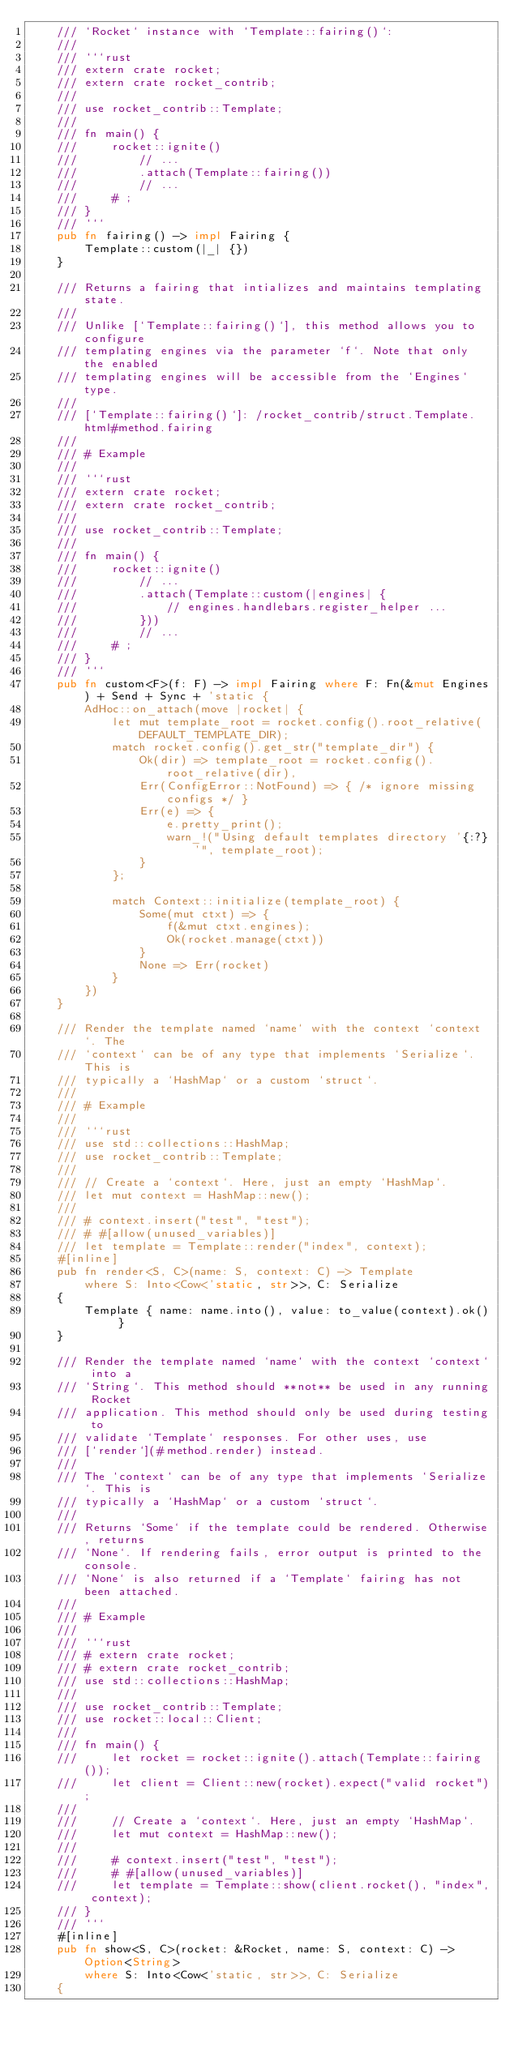Convert code to text. <code><loc_0><loc_0><loc_500><loc_500><_Rust_>    /// `Rocket` instance with `Template::fairing()`:
    ///
    /// ```rust
    /// extern crate rocket;
    /// extern crate rocket_contrib;
    ///
    /// use rocket_contrib::Template;
    ///
    /// fn main() {
    ///     rocket::ignite()
    ///         // ...
    ///         .attach(Template::fairing())
    ///         // ...
    ///     # ;
    /// }
    /// ```
    pub fn fairing() -> impl Fairing {
        Template::custom(|_| {})
    }

    /// Returns a fairing that intializes and maintains templating state.
    ///
    /// Unlike [`Template::fairing()`], this method allows you to configure
    /// templating engines via the parameter `f`. Note that only the enabled
    /// templating engines will be accessible from the `Engines` type.
    ///
    /// [`Template::fairing()`]: /rocket_contrib/struct.Template.html#method.fairing
    ///
    /// # Example
    ///
    /// ```rust
    /// extern crate rocket;
    /// extern crate rocket_contrib;
    ///
    /// use rocket_contrib::Template;
    ///
    /// fn main() {
    ///     rocket::ignite()
    ///         // ...
    ///         .attach(Template::custom(|engines| {
    ///             // engines.handlebars.register_helper ...
    ///         }))
    ///         // ...
    ///     # ;
    /// }
    /// ```
    pub fn custom<F>(f: F) -> impl Fairing where F: Fn(&mut Engines) + Send + Sync + 'static {
        AdHoc::on_attach(move |rocket| {
            let mut template_root = rocket.config().root_relative(DEFAULT_TEMPLATE_DIR);
            match rocket.config().get_str("template_dir") {
                Ok(dir) => template_root = rocket.config().root_relative(dir),
                Err(ConfigError::NotFound) => { /* ignore missing configs */ }
                Err(e) => {
                    e.pretty_print();
                    warn_!("Using default templates directory '{:?}'", template_root);
                }
            };

            match Context::initialize(template_root) {
                Some(mut ctxt) => {
                    f(&mut ctxt.engines);
                    Ok(rocket.manage(ctxt))
                }
                None => Err(rocket)
            }
        })
    }

    /// Render the template named `name` with the context `context`. The
    /// `context` can be of any type that implements `Serialize`. This is
    /// typically a `HashMap` or a custom `struct`.
    ///
    /// # Example
    ///
    /// ```rust
    /// use std::collections::HashMap;
    /// use rocket_contrib::Template;
    ///
    /// // Create a `context`. Here, just an empty `HashMap`.
    /// let mut context = HashMap::new();
    ///
    /// # context.insert("test", "test");
    /// # #[allow(unused_variables)]
    /// let template = Template::render("index", context);
    #[inline]
    pub fn render<S, C>(name: S, context: C) -> Template
        where S: Into<Cow<'static, str>>, C: Serialize
    {
        Template { name: name.into(), value: to_value(context).ok() }
    }

    /// Render the template named `name` with the context `context` into a
    /// `String`. This method should **not** be used in any running Rocket
    /// application. This method should only be used during testing to
    /// validate `Template` responses. For other uses, use
    /// [`render`](#method.render) instead.
    ///
    /// The `context` can be of any type that implements `Serialize`. This is
    /// typically a `HashMap` or a custom `struct`.
    ///
    /// Returns `Some` if the template could be rendered. Otherwise, returns
    /// `None`. If rendering fails, error output is printed to the console.
    /// `None` is also returned if a `Template` fairing has not been attached.
    ///
    /// # Example
    ///
    /// ```rust
    /// # extern crate rocket;
    /// # extern crate rocket_contrib;
    /// use std::collections::HashMap;
    ///
    /// use rocket_contrib::Template;
    /// use rocket::local::Client;
    ///
    /// fn main() {
    ///     let rocket = rocket::ignite().attach(Template::fairing());
    ///     let client = Client::new(rocket).expect("valid rocket");
    ///
    ///     // Create a `context`. Here, just an empty `HashMap`.
    ///     let mut context = HashMap::new();
    ///
    ///     # context.insert("test", "test");
    ///     # #[allow(unused_variables)]
    ///     let template = Template::show(client.rocket(), "index", context);
    /// }
    /// ```
    #[inline]
    pub fn show<S, C>(rocket: &Rocket, name: S, context: C) -> Option<String>
        where S: Into<Cow<'static, str>>, C: Serialize
    {</code> 